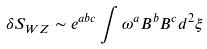<formula> <loc_0><loc_0><loc_500><loc_500>\delta S _ { W Z } \sim e ^ { a b c } \int \omega ^ { a } B ^ { b } B ^ { c } d ^ { 2 } \xi</formula> 